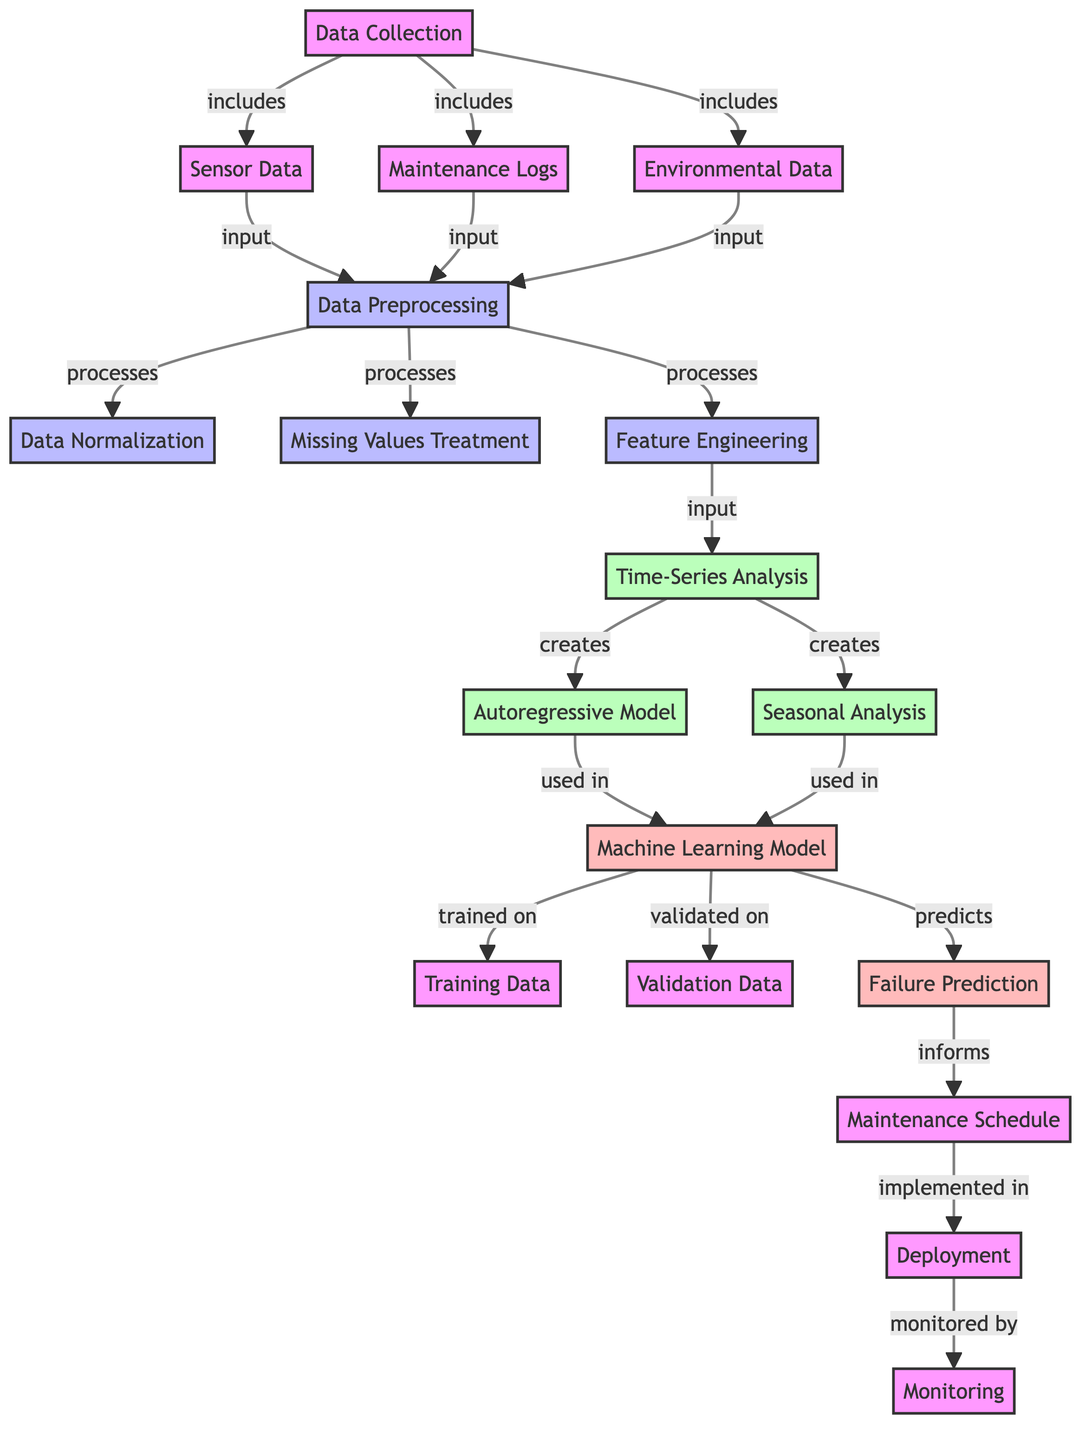What are the three types of data collected? The diagram lists three types of data under the "Data Collection" node: "Sensor Data," "Maintenance Logs," and "Environmental Data." These are essential inputs for further processing.
Answer: Sensor Data, Maintenance Logs, Environmental Data How many preprocessing steps are there? The diagram shows three distinct steps involved in data preprocessing: "Data Normalization," "Missing Values Treatment," and "Feature Engineering." Counting these, we find there are three steps.
Answer: 3 Which analysis methods are created from time-series analysis? The "Time-Series Analysis" node in the diagram leads to the creation of two methods: "Autoregressive Model" and "Seasonal Analysis." These are crucial for understanding different aspects of the time-series data.
Answer: Autoregressive Model, Seasonal Analysis What is the role of the "Machine Learning Model" in this diagram? The "Machine Learning Model" in the diagram is trained on the "Training Data" and validated on the "Validation Data." Its key role is to predict "Failure Prediction" based on the processed data and analysis techniques.
Answer: Predicts Failure Prediction How does the "Maintenance Schedule" relate to predictions? The "Failure Prediction" node informs the "Maintenance Schedule," indicating that the predicted equipment failures will influence when maintenance should be performed. This shows a direct link between prediction and maintenance planning.
Answer: Informs What are the three output actions after deployment mentioned in the diagram? The diagram illustrates the flow after deployment leading to three actions: "Monitoring" is the only action listed directly after "Deployment," but it implies that continuous monitoring occurs once the system is in place. Therefore, there is primarily one clearly defined action mentioned after "Deployment."
Answer: Monitoring How is the data processed before analysis? Before analysis, the data undergoes preprocessing that includes three steps: "Data Normalization," "Missing Values Treatment," and "Feature Engineering." These steps are sequentially necessary for preparing the data for the subsequent analysis stages.
Answer: Data Preprocessing Which nodes are used to train the machine learning model? The "Machine Learning Model" is trained on "Training Data" and validated on "Validation Data," as shown in the diagram. Both of these nodes are crucial inputs for effectively training the model.
Answer: Training Data, Validation Data How many nodes are there in total? By counting all distinct nodes connected in the diagram, including input, process, analysis, output, and deployment nodes, we arrive at a total of eighteen nodes that reflect different stages of the machine learning workflow for predicting equipment failure.
Answer: 18 